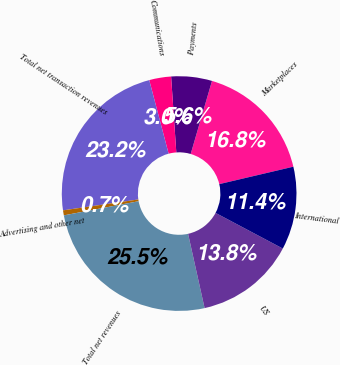Convert chart to OTSL. <chart><loc_0><loc_0><loc_500><loc_500><pie_chart><fcel>Marketplaces<fcel>Payments<fcel>Communications<fcel>Total net transaction revenues<fcel>Advertising and other net<fcel>Total net revenues<fcel>US<fcel>International<nl><fcel>16.81%<fcel>5.61%<fcel>3.01%<fcel>23.19%<fcel>0.69%<fcel>25.51%<fcel>13.76%<fcel>11.44%<nl></chart> 